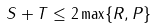<formula> <loc_0><loc_0><loc_500><loc_500>S + T \leq 2 \max \{ R , P \}</formula> 